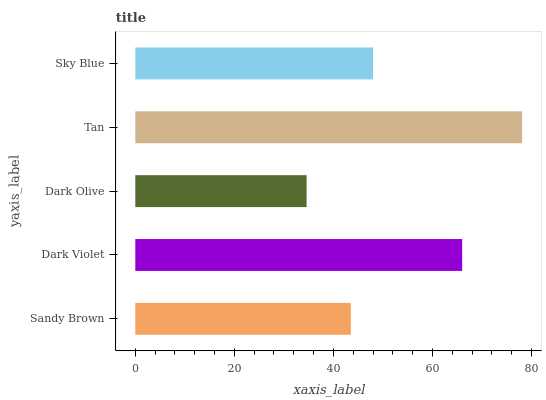Is Dark Olive the minimum?
Answer yes or no. Yes. Is Tan the maximum?
Answer yes or no. Yes. Is Dark Violet the minimum?
Answer yes or no. No. Is Dark Violet the maximum?
Answer yes or no. No. Is Dark Violet greater than Sandy Brown?
Answer yes or no. Yes. Is Sandy Brown less than Dark Violet?
Answer yes or no. Yes. Is Sandy Brown greater than Dark Violet?
Answer yes or no. No. Is Dark Violet less than Sandy Brown?
Answer yes or no. No. Is Sky Blue the high median?
Answer yes or no. Yes. Is Sky Blue the low median?
Answer yes or no. Yes. Is Dark Violet the high median?
Answer yes or no. No. Is Dark Violet the low median?
Answer yes or no. No. 